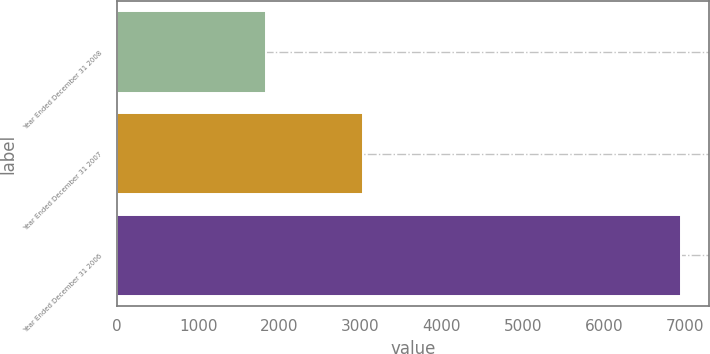<chart> <loc_0><loc_0><loc_500><loc_500><bar_chart><fcel>Year Ended December 31 2008<fcel>Year Ended December 31 2007<fcel>Year Ended December 31 2006<nl><fcel>1836<fcel>3026.2<fcel>6945<nl></chart> 